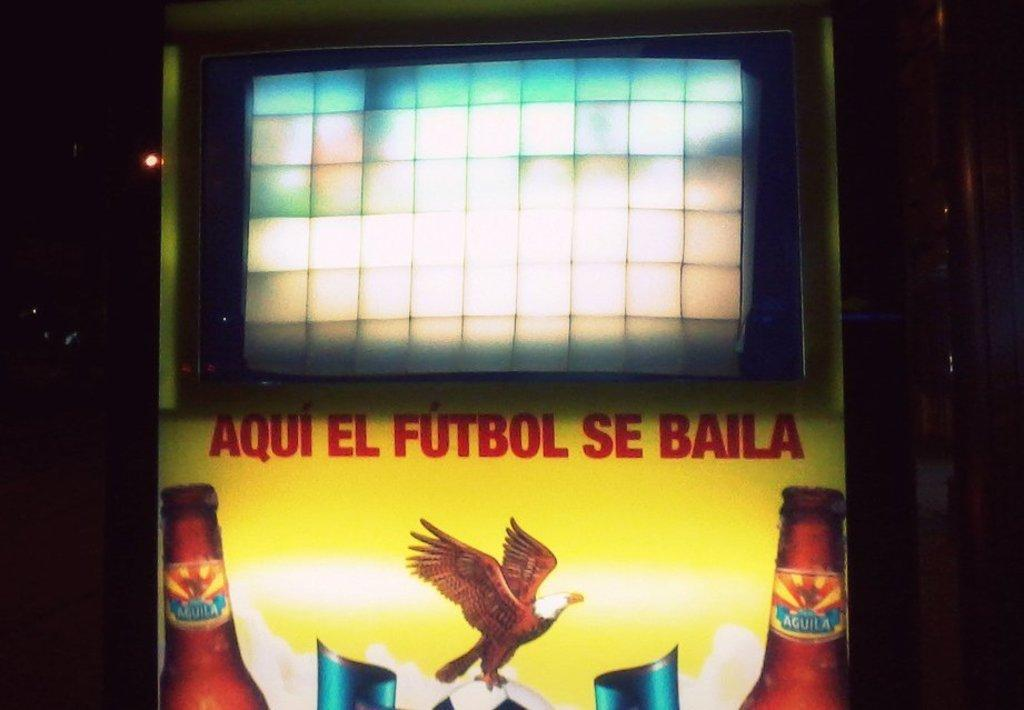<image>
Render a clear and concise summary of the photo. Vending machine written on the front in a soccer teams name Aqui EL FUTBOL SE BAILA. 